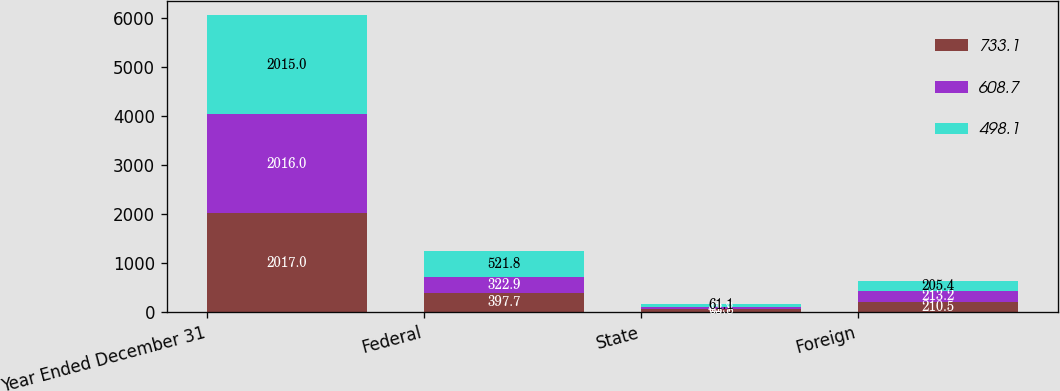Convert chart. <chart><loc_0><loc_0><loc_500><loc_500><stacked_bar_chart><ecel><fcel>Year Ended December 31<fcel>Federal<fcel>State<fcel>Foreign<nl><fcel>733.1<fcel>2017<fcel>397.7<fcel>63.8<fcel>210.5<nl><fcel>608.7<fcel>2016<fcel>322.9<fcel>41.7<fcel>213.2<nl><fcel>498.1<fcel>2015<fcel>521.8<fcel>61.1<fcel>205.4<nl></chart> 